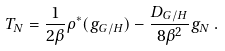Convert formula to latex. <formula><loc_0><loc_0><loc_500><loc_500>T _ { N } = \frac { 1 } { 2 \beta } \rho ^ { * } ( { g } _ { G / H } ) - \frac { D _ { G / H } } { 8 \beta ^ { 2 } } { g } _ { N } \, .</formula> 